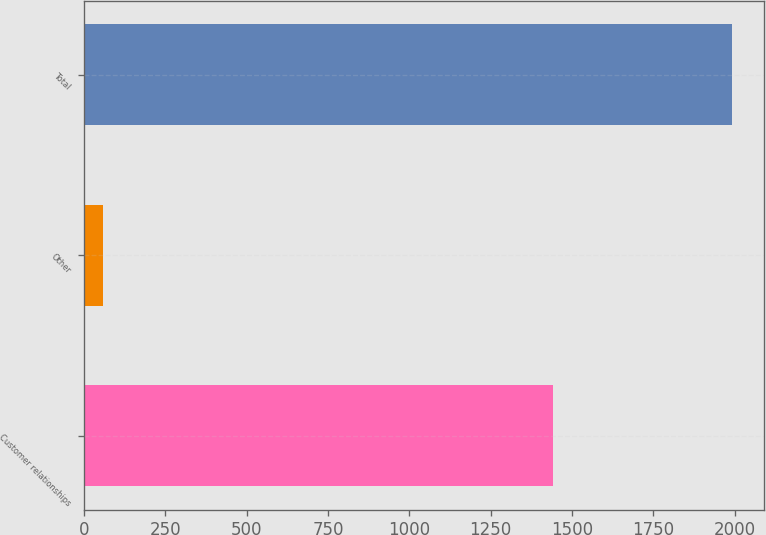Convert chart. <chart><loc_0><loc_0><loc_500><loc_500><bar_chart><fcel>Customer relationships<fcel>Other<fcel>Total<nl><fcel>1442<fcel>59<fcel>1990<nl></chart> 